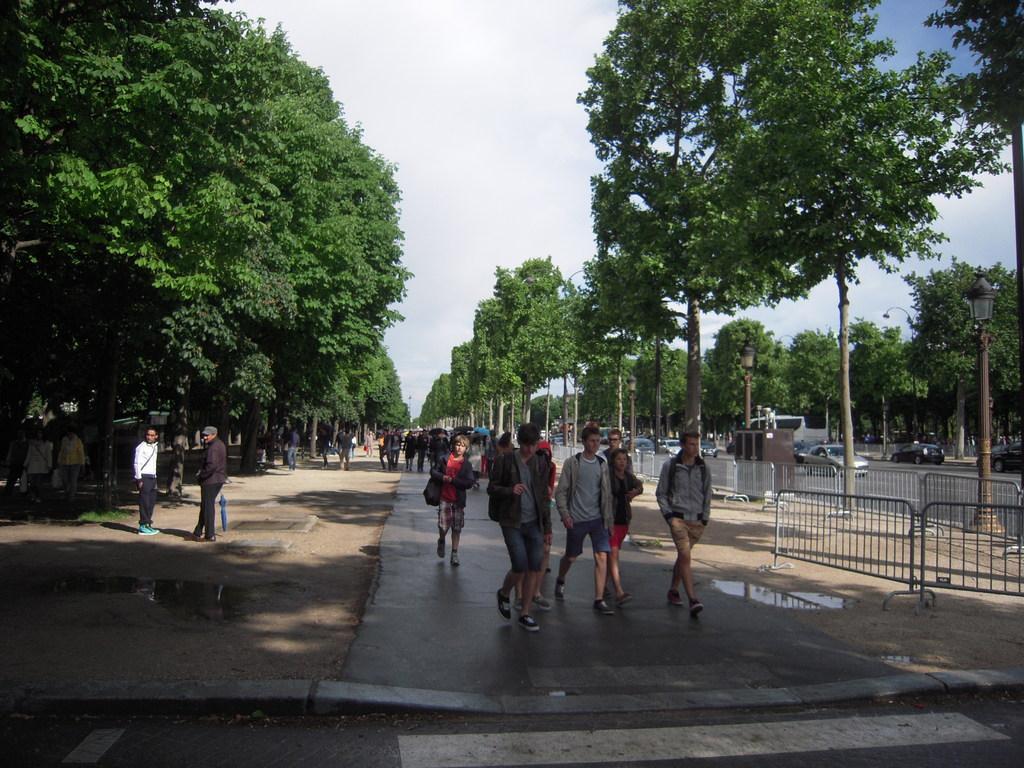In one or two sentences, can you explain what this image depicts? Here in this picture we can see number of people standing and walking on the road and on the right side we can see barricades present and we can see lamp post present and we can see plants and trees covered over there and we can also see cars present on the road and we can see the sky is cloudy. 